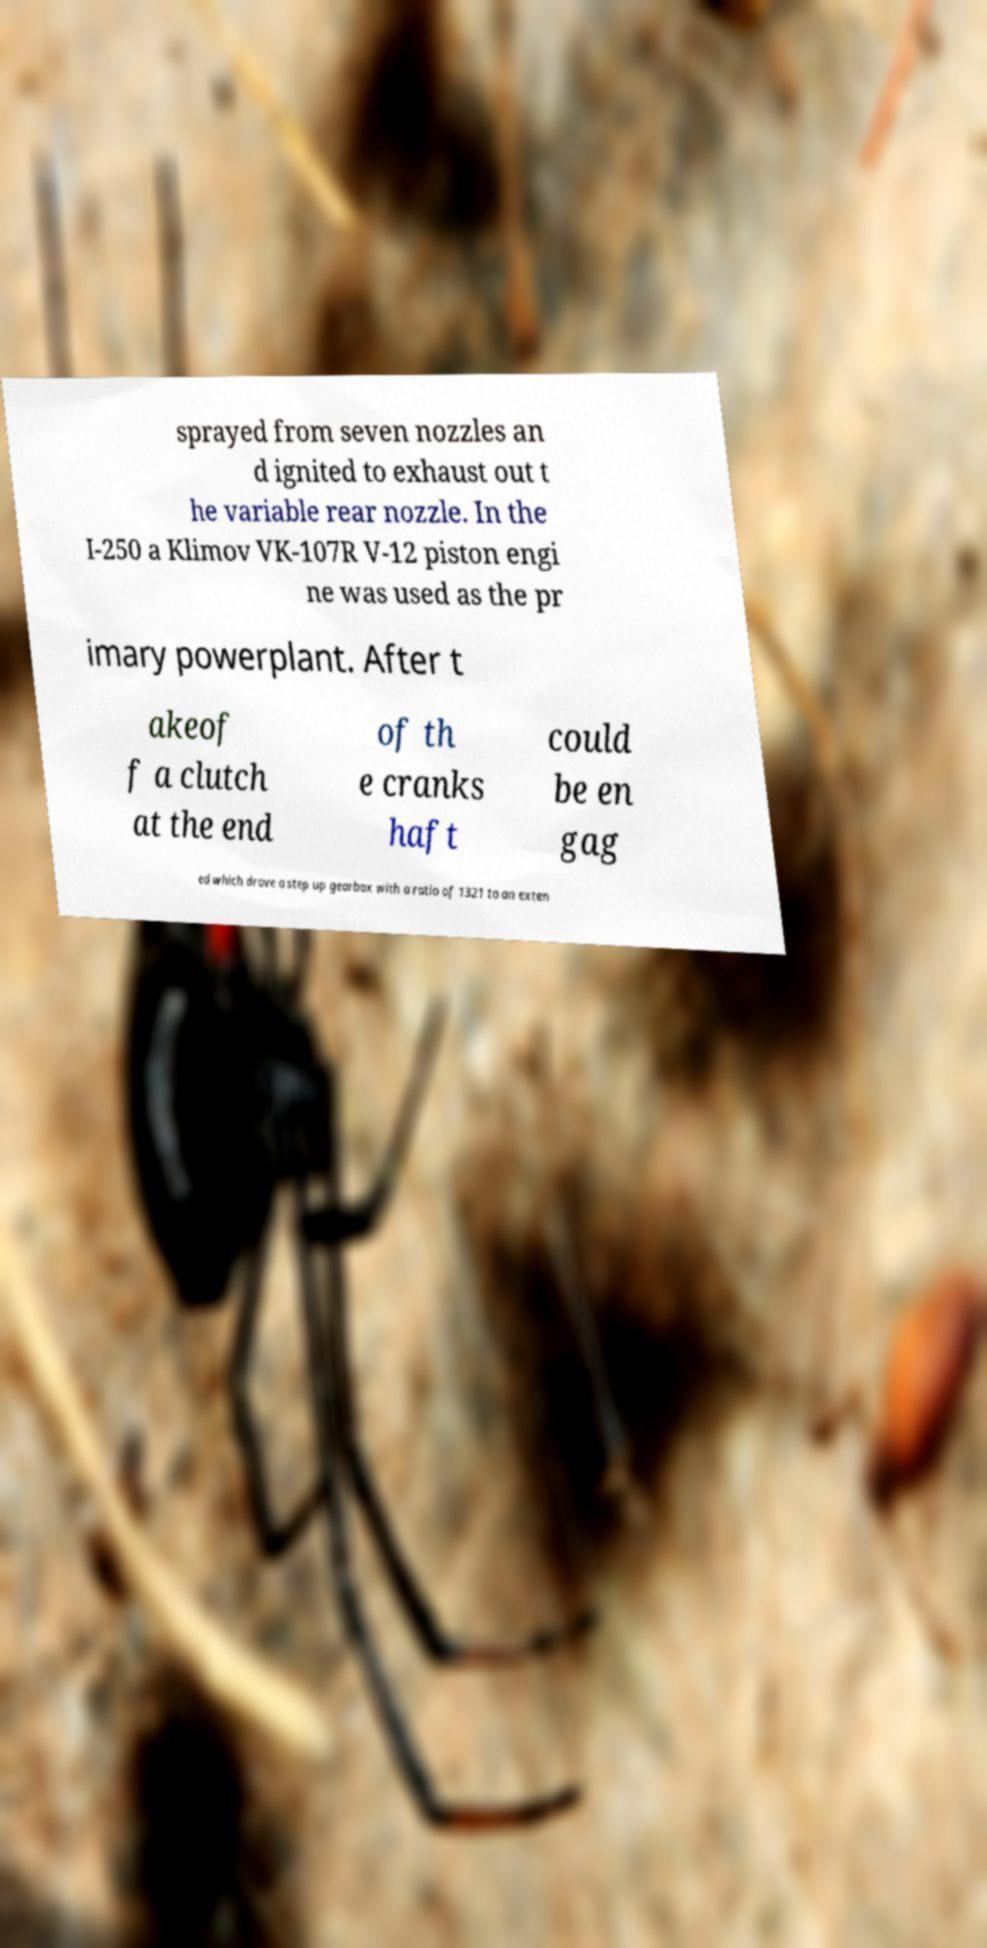I need the written content from this picture converted into text. Can you do that? sprayed from seven nozzles an d ignited to exhaust out t he variable rear nozzle. In the I-250 a Klimov VK-107R V-12 piston engi ne was used as the pr imary powerplant. After t akeof f a clutch at the end of th e cranks haft could be en gag ed which drove a step up gearbox with a ratio of 1321 to an exten 